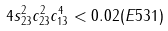<formula> <loc_0><loc_0><loc_500><loc_500>4 s _ { 2 3 } ^ { 2 } c _ { 2 3 } ^ { 2 } c _ { 1 3 } ^ { 4 } < 0 . 0 2 ( E 5 3 1 )</formula> 